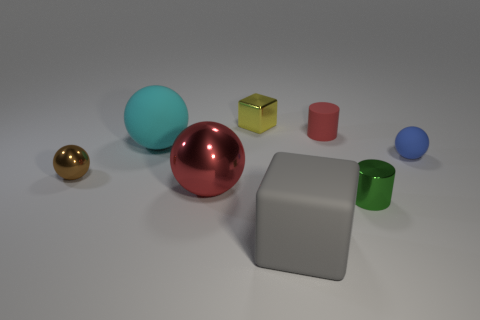Add 1 big cyan balls. How many objects exist? 9 Subtract all yellow cubes. How many cubes are left? 1 Subtract all cylinders. How many objects are left? 6 Subtract 1 balls. How many balls are left? 3 Subtract all cyan cubes. Subtract all purple cylinders. How many cubes are left? 2 Subtract all green balls. How many yellow blocks are left? 1 Subtract all large gray cubes. Subtract all blue balls. How many objects are left? 6 Add 7 green things. How many green things are left? 8 Add 2 large purple balls. How many large purple balls exist? 2 Subtract 1 red balls. How many objects are left? 7 